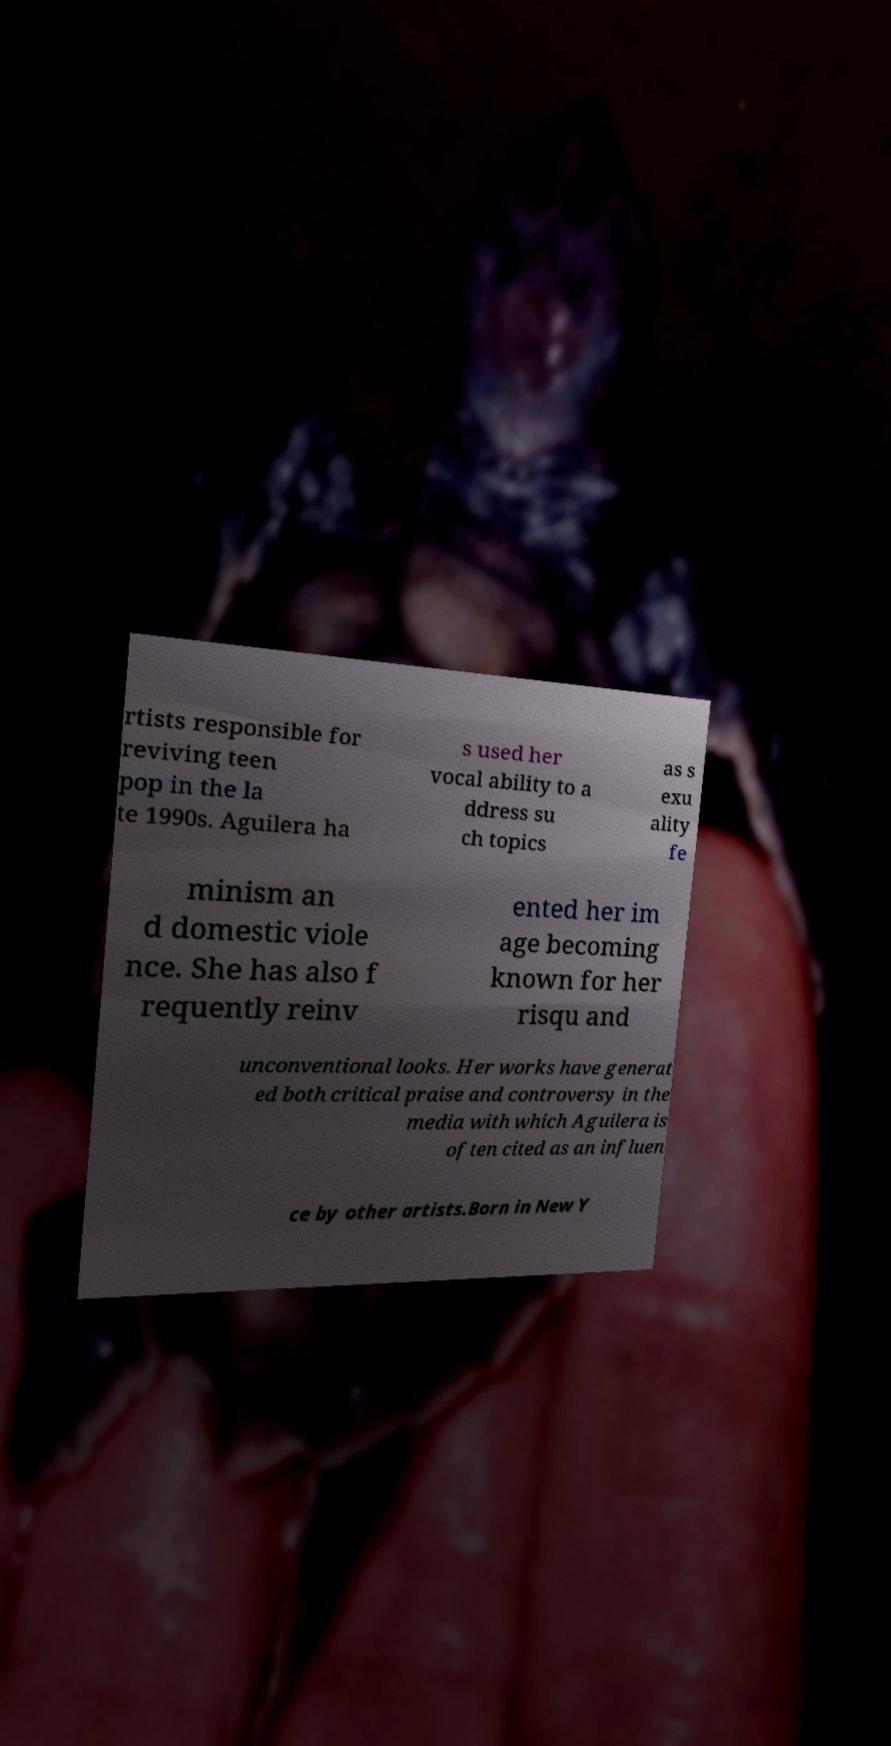Could you extract and type out the text from this image? rtists responsible for reviving teen pop in the la te 1990s. Aguilera ha s used her vocal ability to a ddress su ch topics as s exu ality fe minism an d domestic viole nce. She has also f requently reinv ented her im age becoming known for her risqu and unconventional looks. Her works have generat ed both critical praise and controversy in the media with which Aguilera is often cited as an influen ce by other artists.Born in New Y 